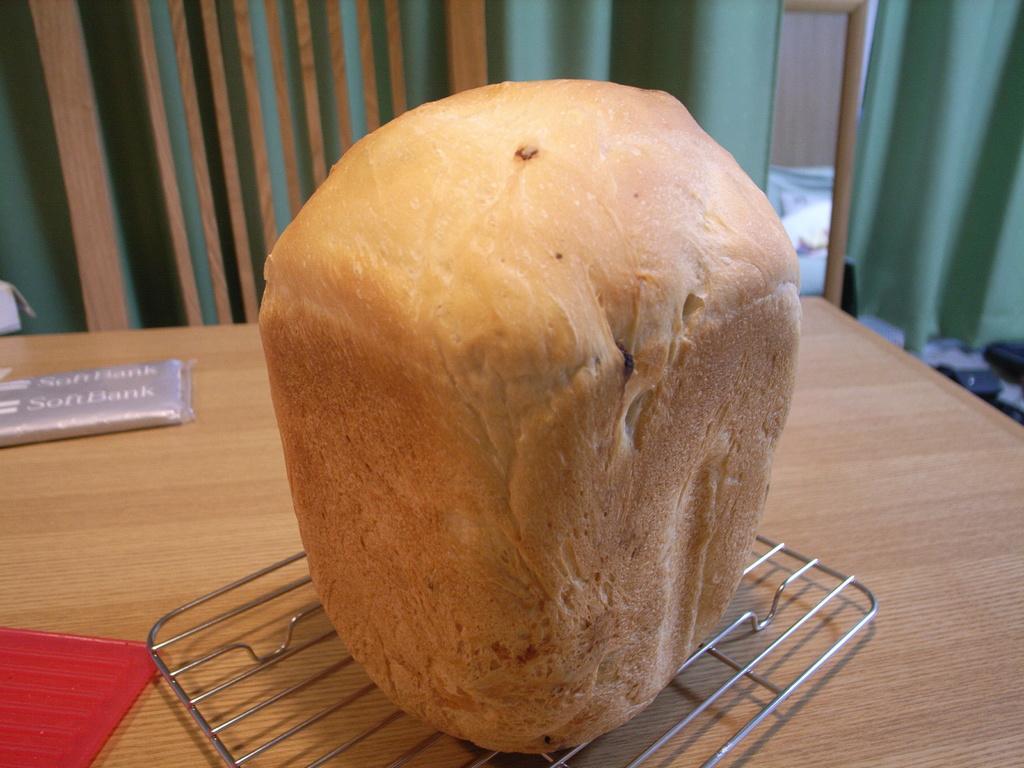In one or two sentences, can you explain what this image depicts? In this image we can see a wooden surface. On that there is a steel stand and some other things. On the stand there is a food item. In the back there are curtains. Also there are wooden poles. 